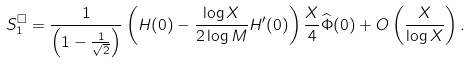Convert formula to latex. <formula><loc_0><loc_0><loc_500><loc_500>S _ { 1 } ^ { \square } & = \frac { 1 } { \left ( 1 - \frac { 1 } { \sqrt { 2 } } \right ) } \left ( H ( 0 ) - \frac { \log X } { 2 \log M } H ^ { \prime } ( 0 ) \right ) \frac { X } { 4 } \widehat { \Phi } ( 0 ) + O \left ( \frac { X } { \log X } \right ) .</formula> 